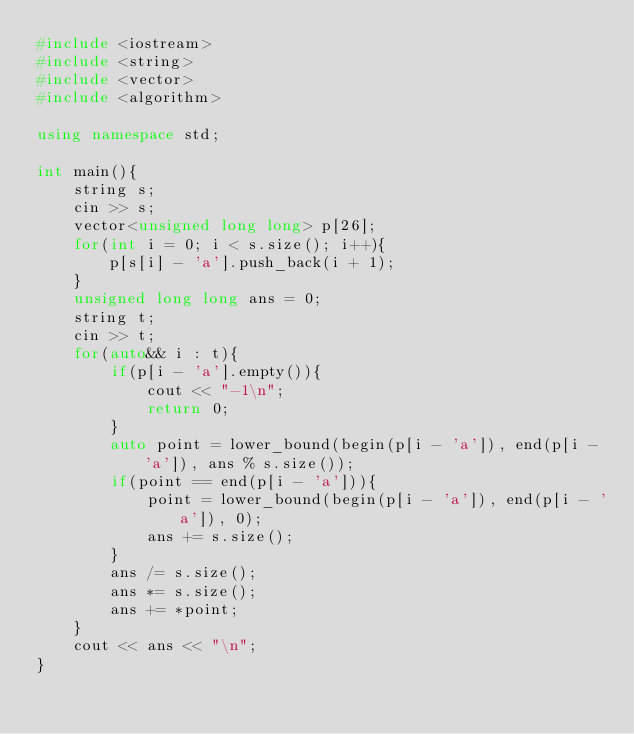Convert code to text. <code><loc_0><loc_0><loc_500><loc_500><_C++_>#include <iostream>
#include <string>
#include <vector>
#include <algorithm>

using namespace std;

int main(){
    string s;
    cin >> s;
    vector<unsigned long long> p[26];
    for(int i = 0; i < s.size(); i++){
        p[s[i] - 'a'].push_back(i + 1);
    }
    unsigned long long ans = 0;
    string t;
    cin >> t;
    for(auto&& i : t){
        if(p[i - 'a'].empty()){
            cout << "-1\n";
            return 0;
        }
        auto point = lower_bound(begin(p[i - 'a']), end(p[i - 'a']), ans % s.size());
        if(point == end(p[i - 'a'])){
            point = lower_bound(begin(p[i - 'a']), end(p[i - 'a']), 0);
            ans += s.size();
        }
        ans /= s.size();
        ans *= s.size();
        ans += *point;
    }
    cout << ans << "\n";
}</code> 